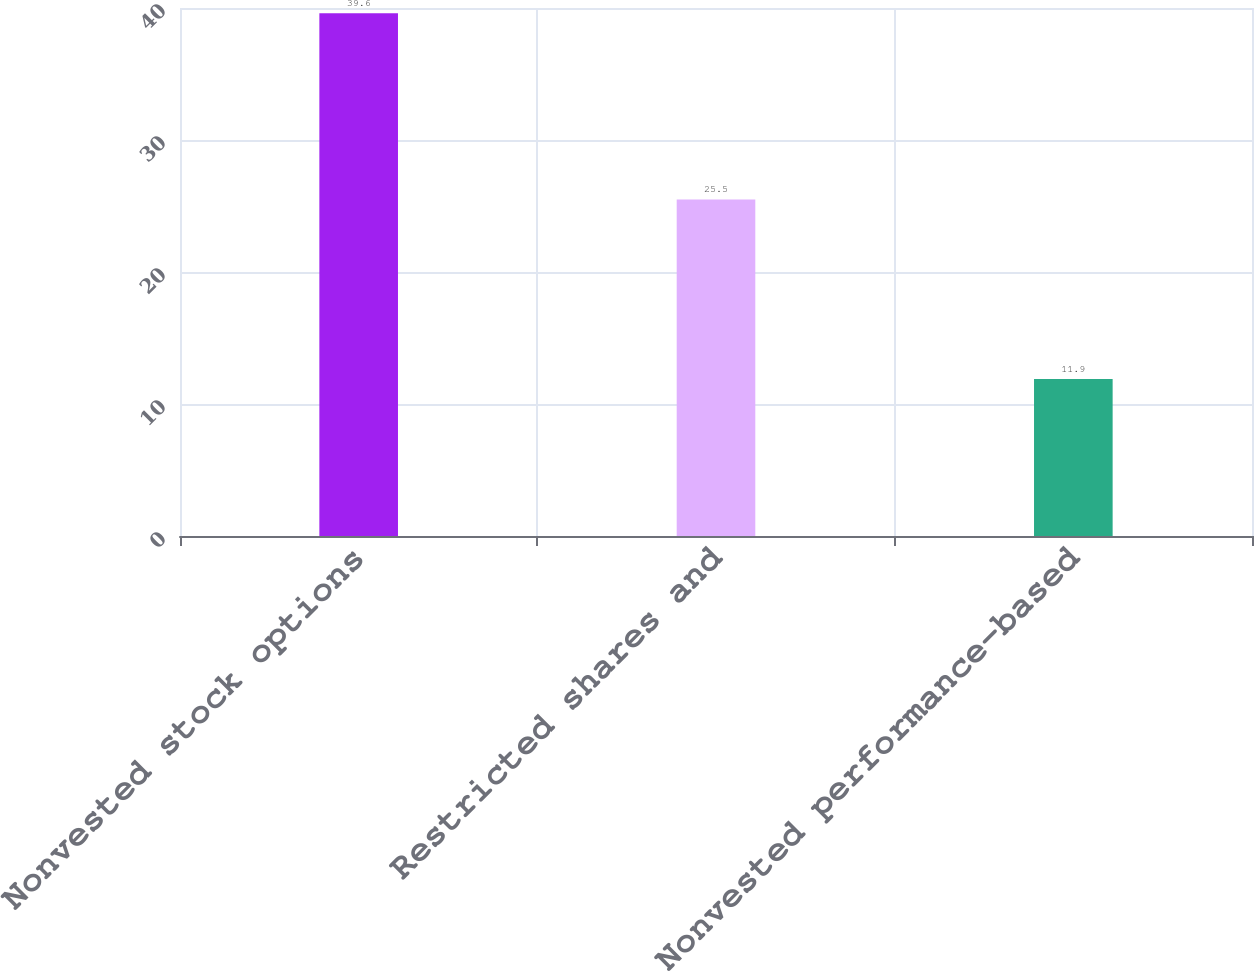Convert chart to OTSL. <chart><loc_0><loc_0><loc_500><loc_500><bar_chart><fcel>Nonvested stock options<fcel>Restricted shares and<fcel>Nonvested performance-based<nl><fcel>39.6<fcel>25.5<fcel>11.9<nl></chart> 